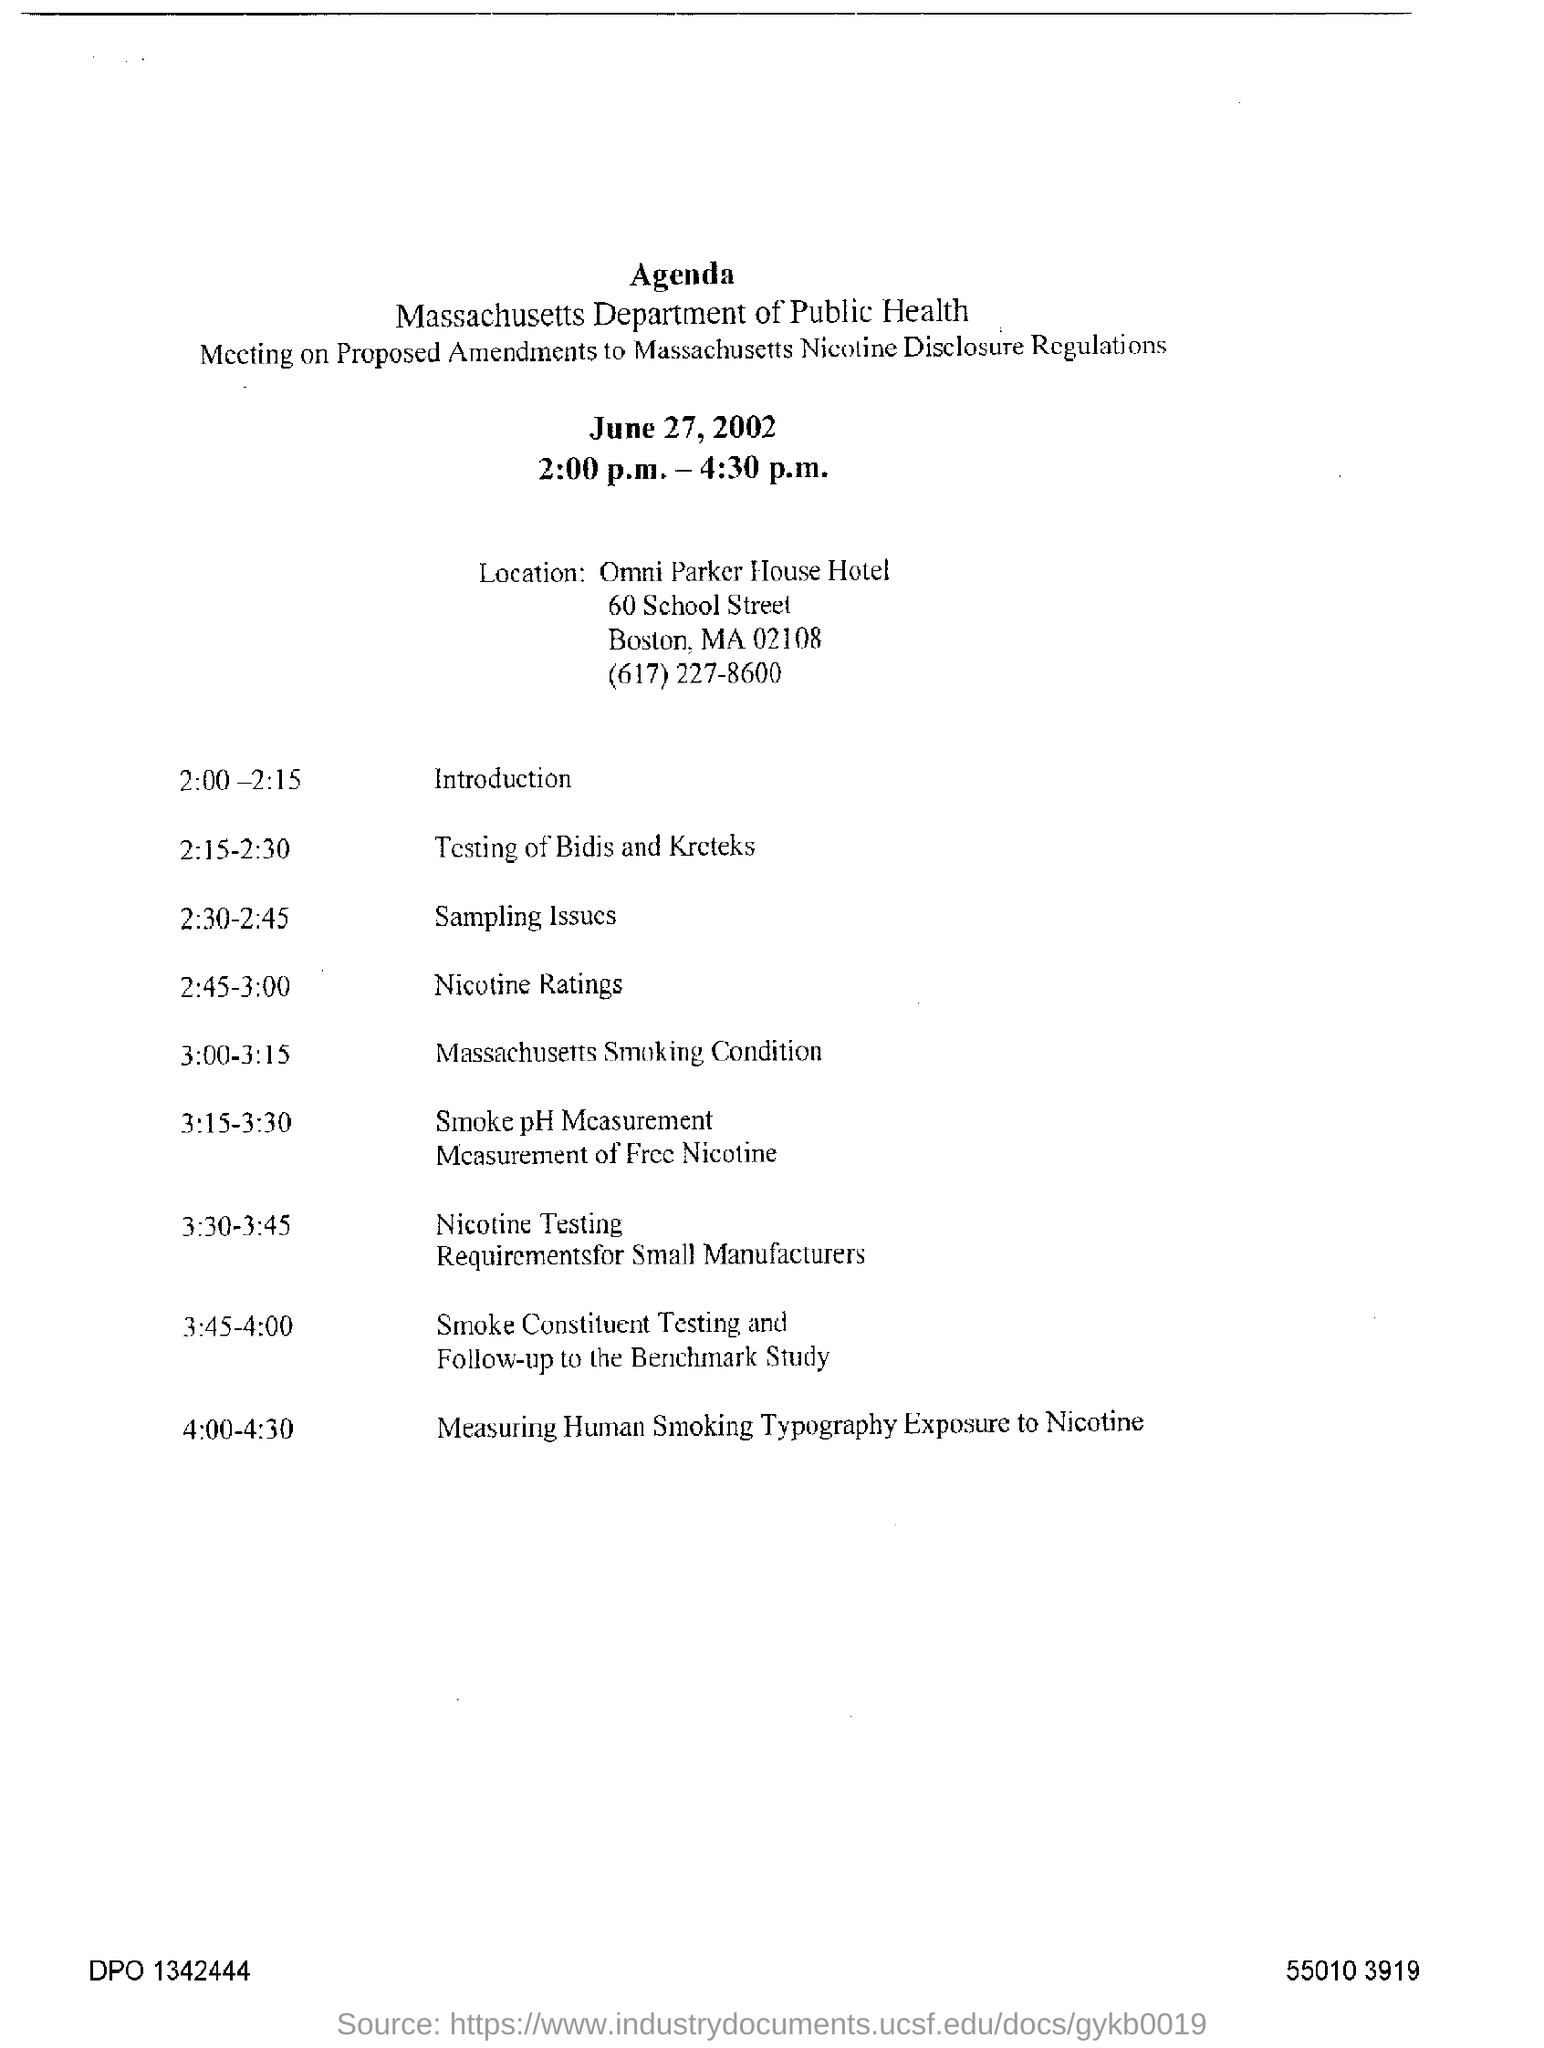What is the name of department for public health?
Your answer should be compact. Massachusetts Department of Public Health. On which day meeting held for proposed amendments?
Your answer should be very brief. June 27 , 2002. What is the location of the meeting ?
Offer a very short reply. Omni parker house hotel. What is the period of time for the measuring human smoking typography exposure to nicotine?
Give a very brief answer. 4:00-4:30. What is the contact number of massachusetts department of public health?
Give a very brief answer. (617)227-8600. 